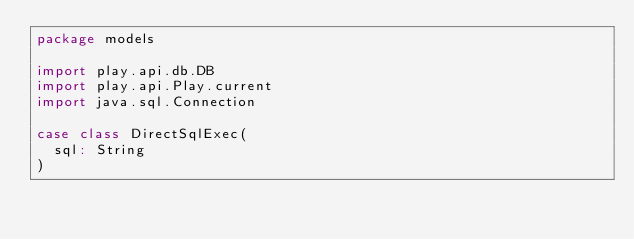Convert code to text. <code><loc_0><loc_0><loc_500><loc_500><_Scala_>package models

import play.api.db.DB
import play.api.Play.current
import java.sql.Connection

case class DirectSqlExec(
  sql: String
)

</code> 